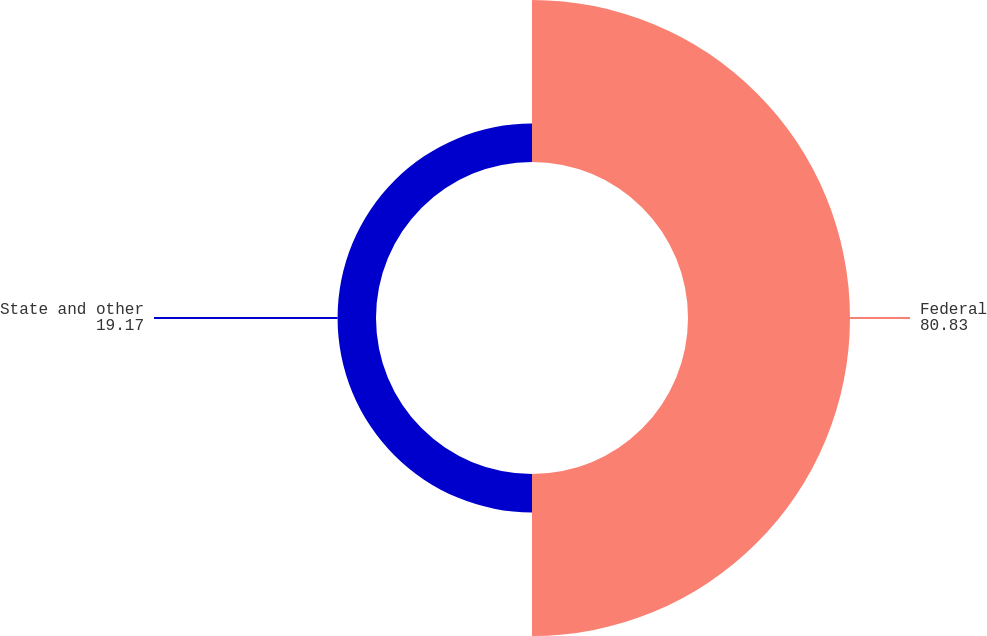<chart> <loc_0><loc_0><loc_500><loc_500><pie_chart><fcel>Federal<fcel>State and other<nl><fcel>80.83%<fcel>19.17%<nl></chart> 